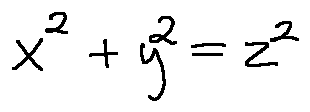<formula> <loc_0><loc_0><loc_500><loc_500>x ^ { 2 } + y ^ { 2 } = z ^ { 2 }</formula> 